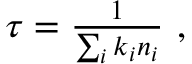<formula> <loc_0><loc_0><loc_500><loc_500>\begin{array} { r } { \tau = \frac { 1 } { \sum _ { i } k _ { i } n _ { i } } , } \end{array}</formula> 